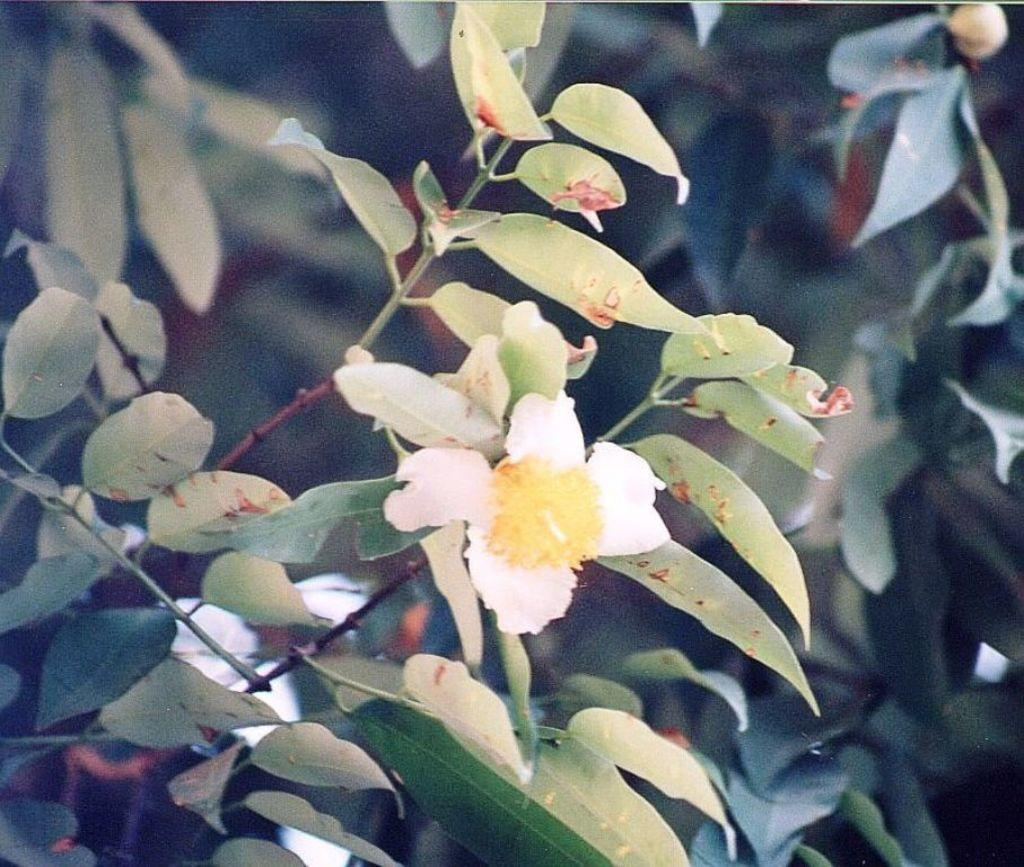What type of flower is in the image? There is a white flower in the image. How is the flower described? The flower is described as beautiful. What color are the leaves surrounding the flower? There are many green leaves visible in the image. What time of day is depicted in the image? The image does not show any indication of time, so it is not possible to determine the hour. 